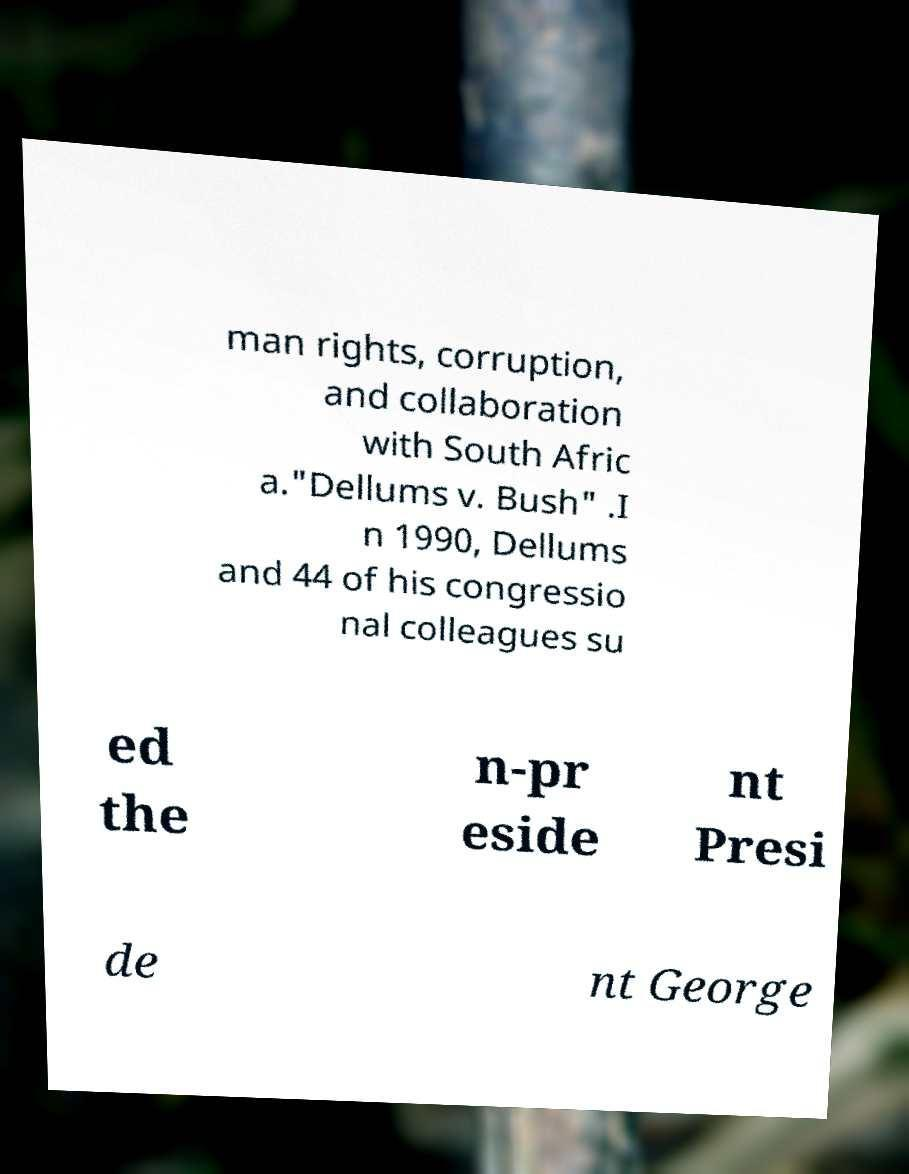For documentation purposes, I need the text within this image transcribed. Could you provide that? man rights, corruption, and collaboration with South Afric a."Dellums v. Bush" .I n 1990, Dellums and 44 of his congressio nal colleagues su ed the n-pr eside nt Presi de nt George 